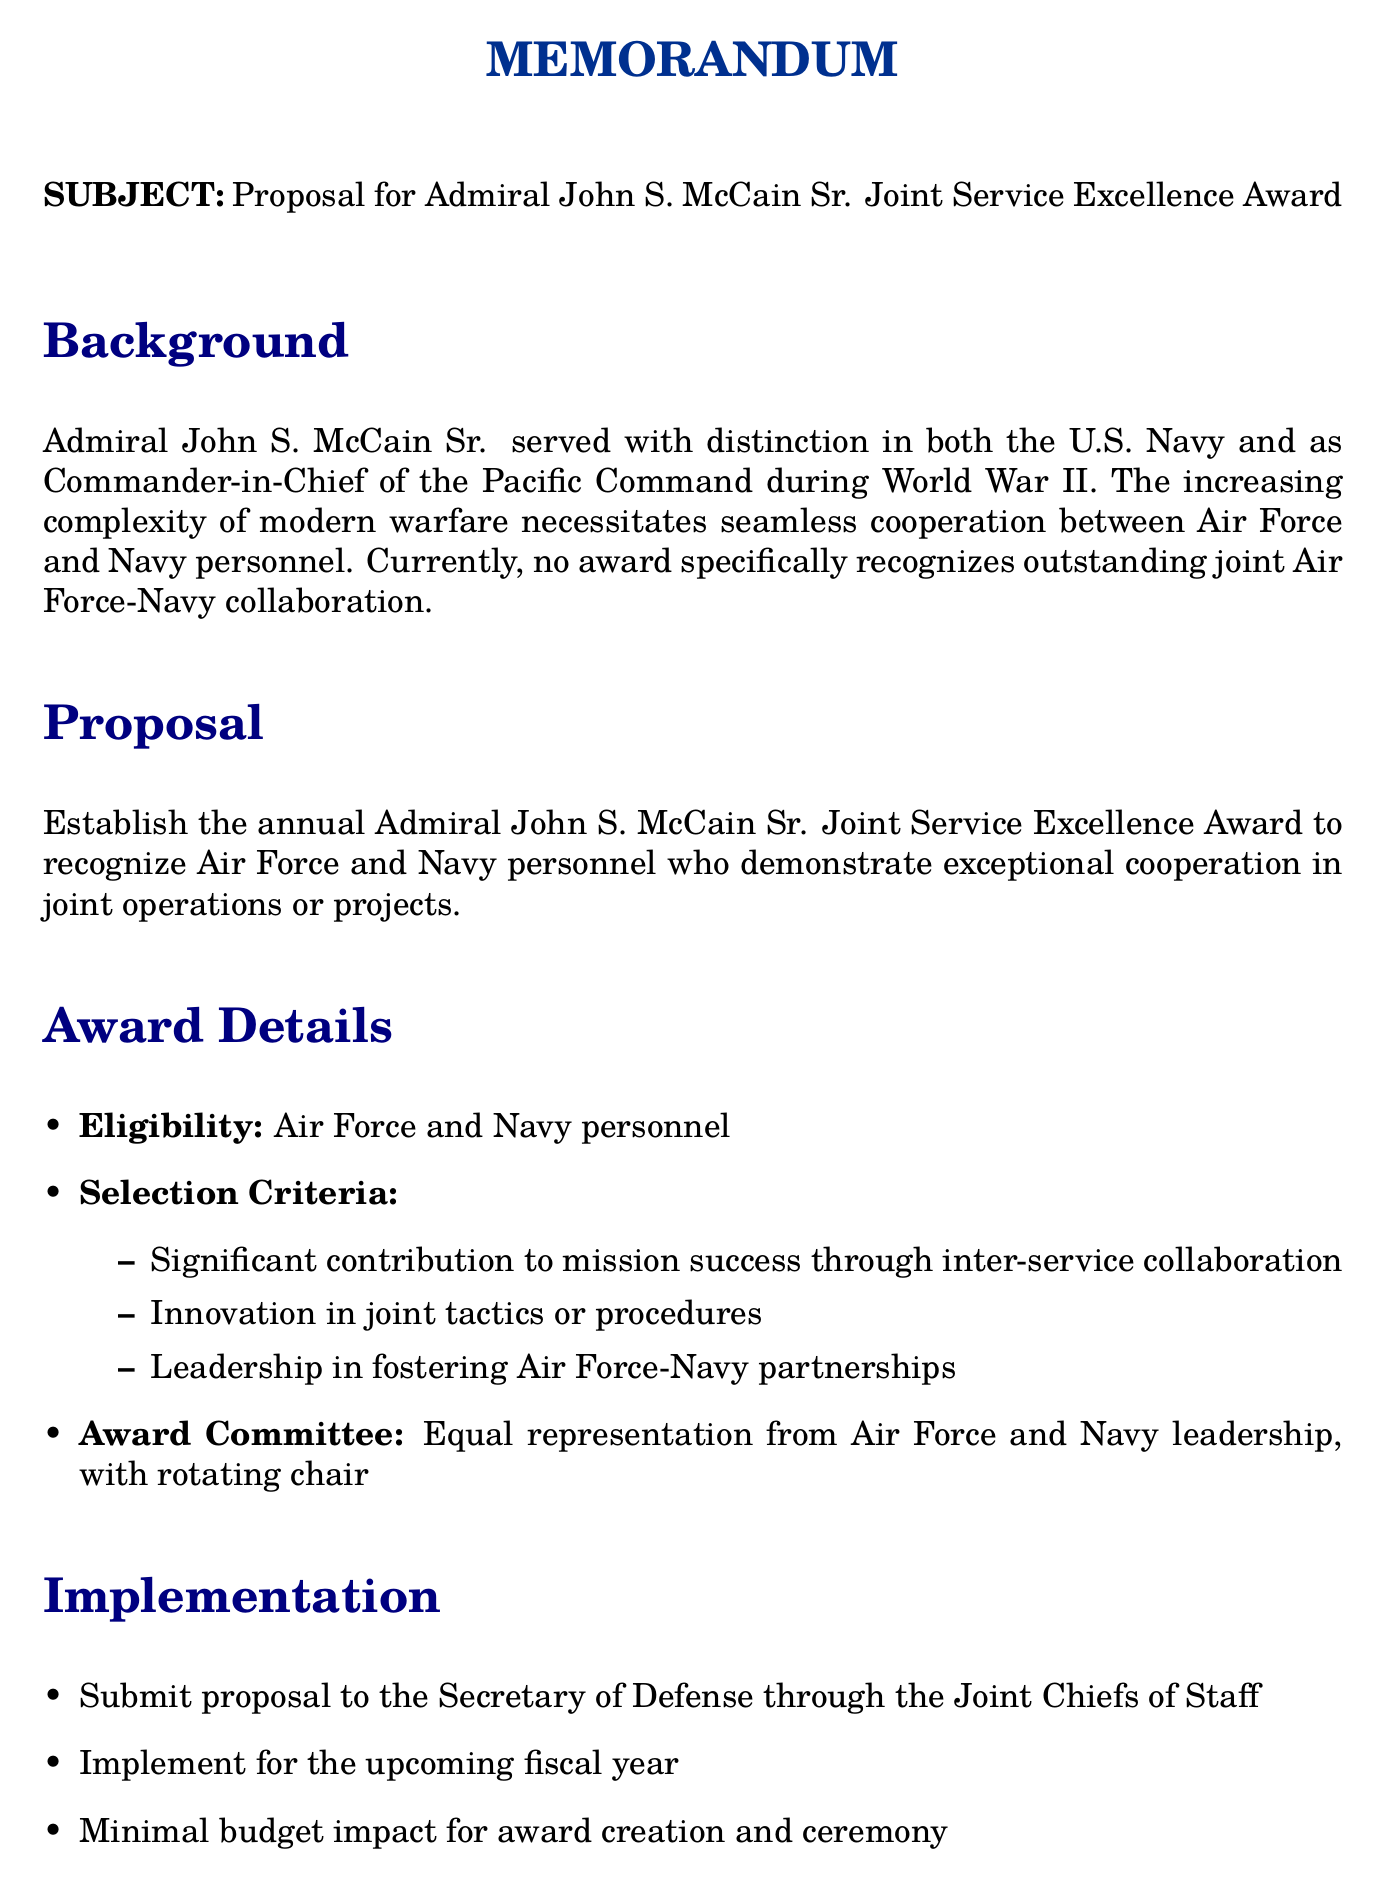What is the subject of the memo? The subject of the memo is to propose an award which is titled "Proposal for Admiral John S. McCain Sr. Joint Service Excellence Award."
Answer: Proposal for Admiral John S. McCain Sr. Joint Service Excellence Award Who is the award named after? The award is named after a distinguished military leader who served with honor in both the U.S. Navy and the Pacific Command.
Answer: Admiral John S. McCain Sr What is the frequency of the award? The frequency of the award is mentioned explicitly in the document.
Answer: Annual What are the eligibility criteria for the award? The document states that the eligibility includes "Air Force and Navy personnel."
Answer: Air Force and Navy personnel What is one of the benefits of establishing this award? The document outlines that the award will "enhance cooperation" between branches of the military.
Answer: Enhance cooperation What is the selection criterion about innovation? The selection criteria specify that innovation should be in "joint tactics or procedures."
Answer: Joint tactics or procedures What is the composition of the award committee? The document states the award committee will have equal representation from both branches of the military leadership.
Answer: Equal representation from Air Force and Navy leadership What is the proposed implementation timeline? The timeline for implementing the award is detailed as being for the "upcoming fiscal year."
Answer: Upcoming fiscal year Who is the signature attributed to in the document? The document indicates the signature belongs to a retired Air Force General.
Answer: Retired Air Force General 